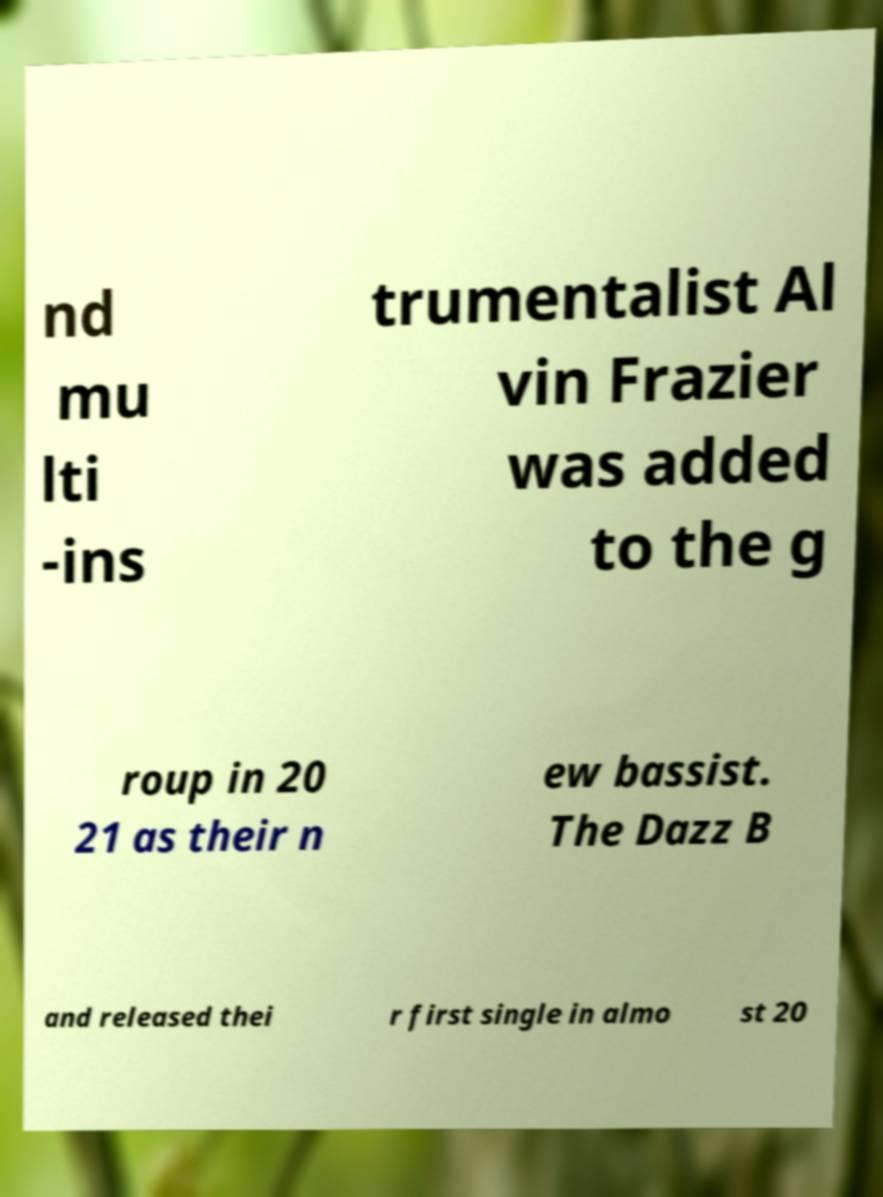Please read and relay the text visible in this image. What does it say? nd mu lti -ins trumentalist Al vin Frazier was added to the g roup in 20 21 as their n ew bassist. The Dazz B and released thei r first single in almo st 20 